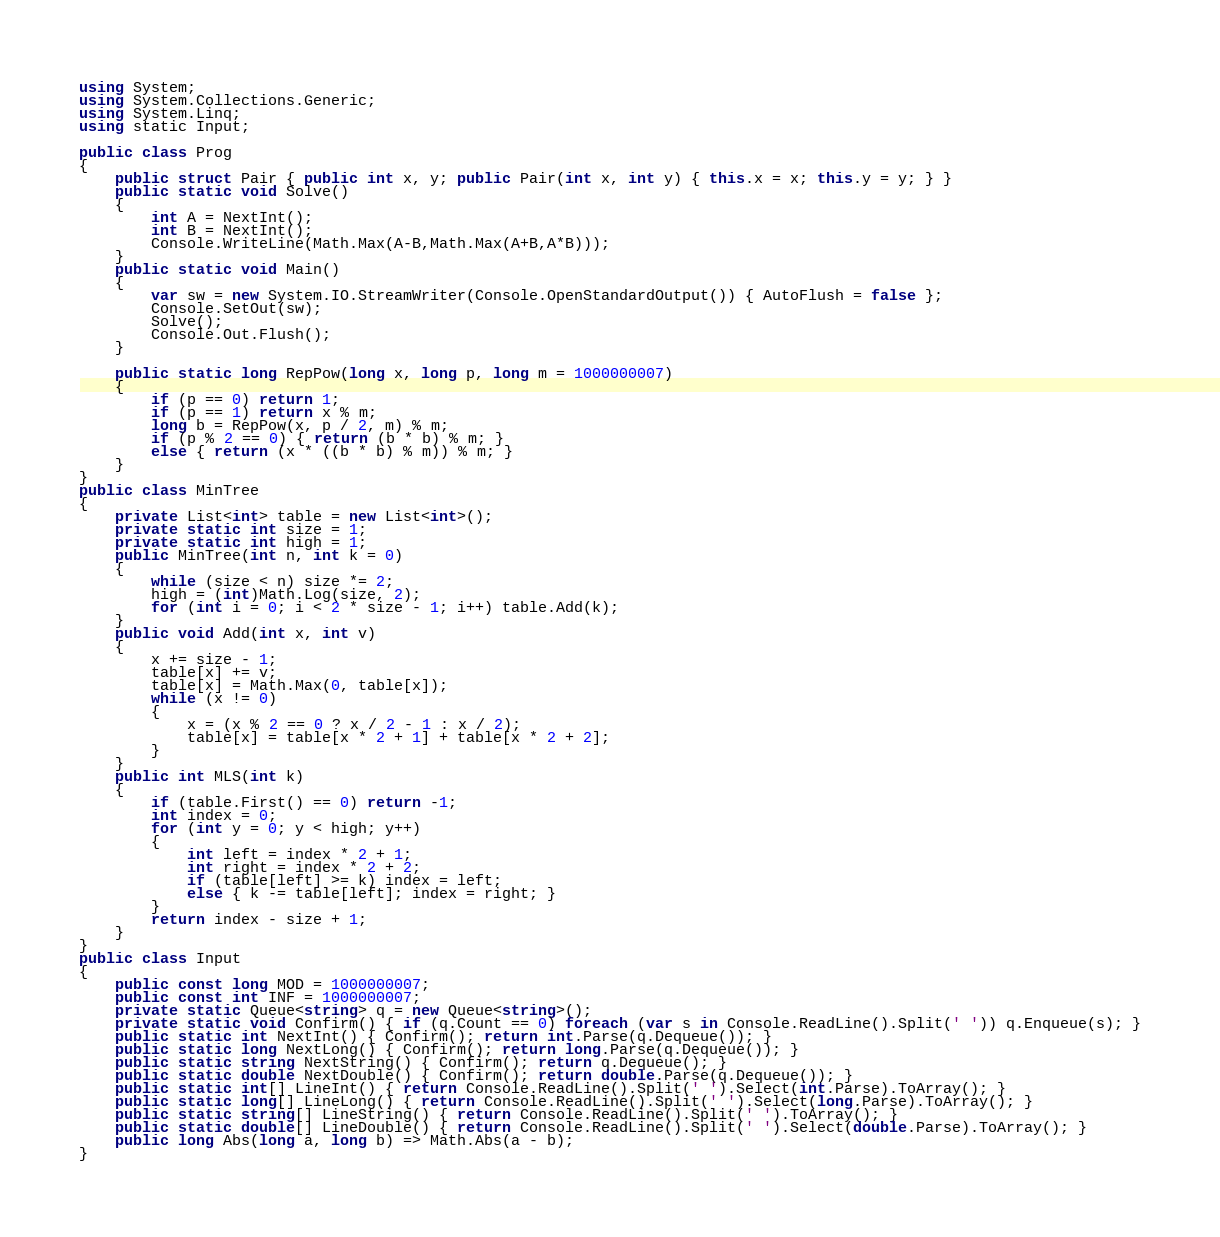Convert code to text. <code><loc_0><loc_0><loc_500><loc_500><_C#_>using System;
using System.Collections.Generic;
using System.Linq;
using static Input;

public class Prog
{
    public struct Pair { public int x, y; public Pair(int x, int y) { this.x = x; this.y = y; } }
    public static void Solve()
    {
        int A = NextInt();
        int B = NextInt();
        Console.WriteLine(Math.Max(A-B,Math.Max(A+B,A*B)));
    }
    public static void Main()
    {
        var sw = new System.IO.StreamWriter(Console.OpenStandardOutput()) { AutoFlush = false };
        Console.SetOut(sw);
        Solve();
        Console.Out.Flush();
    }

    public static long RepPow(long x, long p, long m = 1000000007)
    {
        if (p == 0) return 1;
        if (p == 1) return x % m;
        long b = RepPow(x, p / 2, m) % m;
        if (p % 2 == 0) { return (b * b) % m; }
        else { return (x * ((b * b) % m)) % m; }
    }
}
public class MinTree
{
    private List<int> table = new List<int>();
    private static int size = 1;
    private static int high = 1;
    public MinTree(int n, int k = 0)
    {
        while (size < n) size *= 2;
        high = (int)Math.Log(size, 2);
        for (int i = 0; i < 2 * size - 1; i++) table.Add(k);
    }
    public void Add(int x, int v)
    {
        x += size - 1;
        table[x] += v;
        table[x] = Math.Max(0, table[x]);
        while (x != 0)
        {
            x = (x % 2 == 0 ? x / 2 - 1 : x / 2);
            table[x] = table[x * 2 + 1] + table[x * 2 + 2];
        }
    }
    public int MLS(int k)
    {
        if (table.First() == 0) return -1;
        int index = 0;
        for (int y = 0; y < high; y++)
        {
            int left = index * 2 + 1;
            int right = index * 2 + 2;
            if (table[left] >= k) index = left;
            else { k -= table[left]; index = right; }
        }
        return index - size + 1;
    }
}
public class Input
{
    public const long MOD = 1000000007;
    public const int INF = 1000000007;
    private static Queue<string> q = new Queue<string>();
    private static void Confirm() { if (q.Count == 0) foreach (var s in Console.ReadLine().Split(' ')) q.Enqueue(s); }
    public static int NextInt() { Confirm(); return int.Parse(q.Dequeue()); }
    public static long NextLong() { Confirm(); return long.Parse(q.Dequeue()); }
    public static string NextString() { Confirm(); return q.Dequeue(); }
    public static double NextDouble() { Confirm(); return double.Parse(q.Dequeue()); }
    public static int[] LineInt() { return Console.ReadLine().Split(' ').Select(int.Parse).ToArray(); }
    public static long[] LineLong() { return Console.ReadLine().Split(' ').Select(long.Parse).ToArray(); }
    public static string[] LineString() { return Console.ReadLine().Split(' ').ToArray(); }
    public static double[] LineDouble() { return Console.ReadLine().Split(' ').Select(double.Parse).ToArray(); }
    public long Abs(long a, long b) => Math.Abs(a - b);
}
</code> 